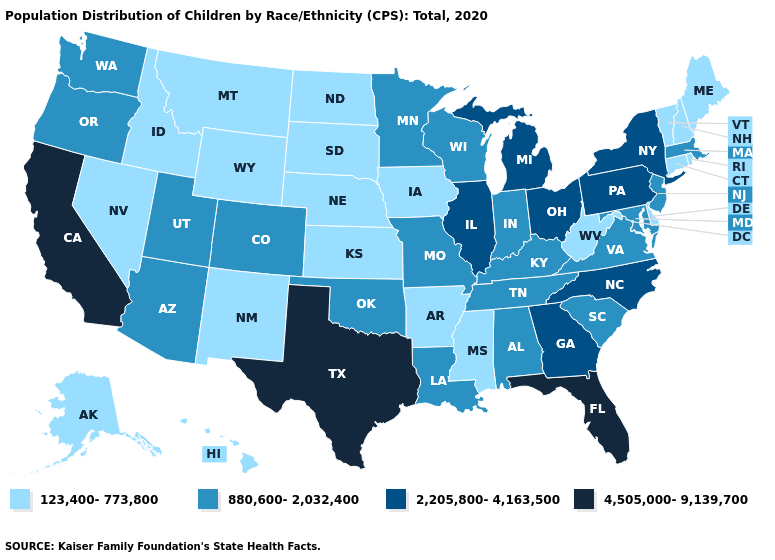Does Minnesota have the lowest value in the USA?
Short answer required. No. What is the value of Hawaii?
Write a very short answer. 123,400-773,800. What is the highest value in the USA?
Be succinct. 4,505,000-9,139,700. What is the highest value in the USA?
Keep it brief. 4,505,000-9,139,700. Among the states that border Colorado , does New Mexico have the lowest value?
Answer briefly. Yes. What is the lowest value in the USA?
Keep it brief. 123,400-773,800. Does South Dakota have a higher value than Illinois?
Answer briefly. No. Name the states that have a value in the range 880,600-2,032,400?
Short answer required. Alabama, Arizona, Colorado, Indiana, Kentucky, Louisiana, Maryland, Massachusetts, Minnesota, Missouri, New Jersey, Oklahoma, Oregon, South Carolina, Tennessee, Utah, Virginia, Washington, Wisconsin. Does Louisiana have a higher value than Pennsylvania?
Answer briefly. No. Which states have the highest value in the USA?
Write a very short answer. California, Florida, Texas. Among the states that border Delaware , does New Jersey have the lowest value?
Write a very short answer. Yes. Among the states that border Ohio , which have the lowest value?
Concise answer only. West Virginia. Which states have the highest value in the USA?
Write a very short answer. California, Florida, Texas. Name the states that have a value in the range 123,400-773,800?
Concise answer only. Alaska, Arkansas, Connecticut, Delaware, Hawaii, Idaho, Iowa, Kansas, Maine, Mississippi, Montana, Nebraska, Nevada, New Hampshire, New Mexico, North Dakota, Rhode Island, South Dakota, Vermont, West Virginia, Wyoming. Name the states that have a value in the range 123,400-773,800?
Concise answer only. Alaska, Arkansas, Connecticut, Delaware, Hawaii, Idaho, Iowa, Kansas, Maine, Mississippi, Montana, Nebraska, Nevada, New Hampshire, New Mexico, North Dakota, Rhode Island, South Dakota, Vermont, West Virginia, Wyoming. 